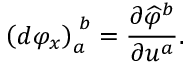<formula> <loc_0><loc_0><loc_500><loc_500>\left ( d \varphi _ { x } \right ) _ { a } ^ { \, b } = { \frac { \partial { \widehat { \varphi } } ^ { b } } { \partial u ^ { a } } } .</formula> 